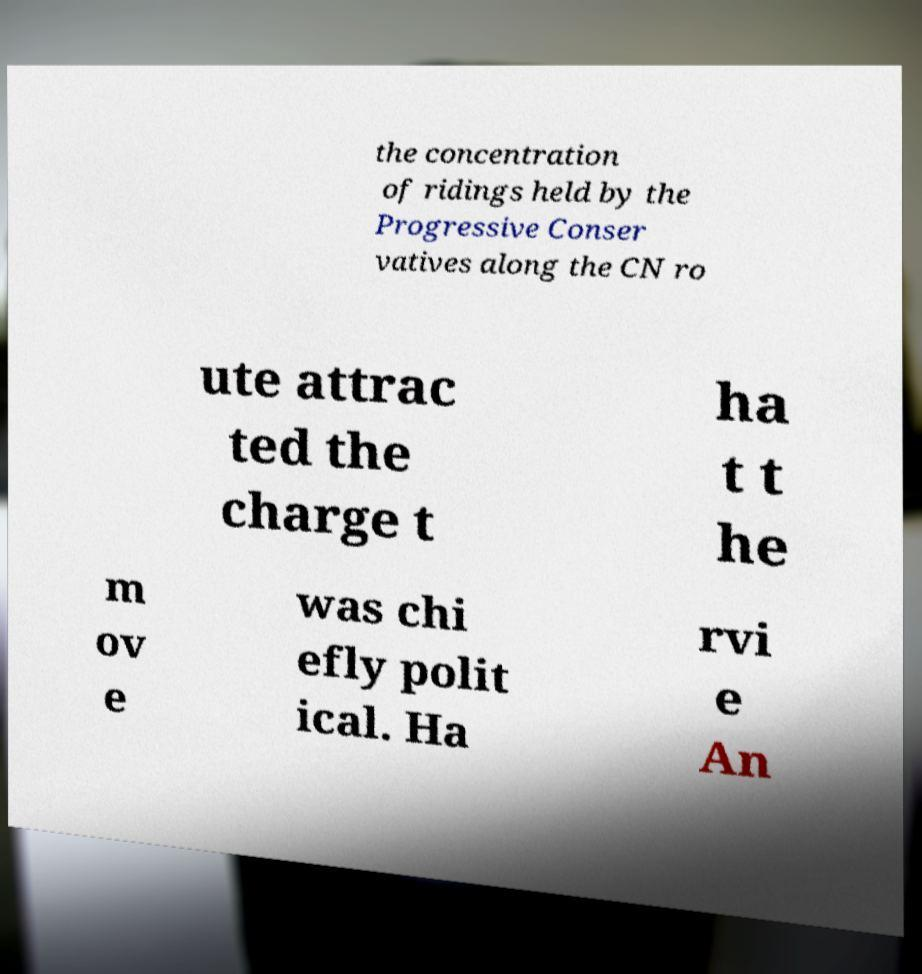Could you extract and type out the text from this image? the concentration of ridings held by the Progressive Conser vatives along the CN ro ute attrac ted the charge t ha t t he m ov e was chi efly polit ical. Ha rvi e An 